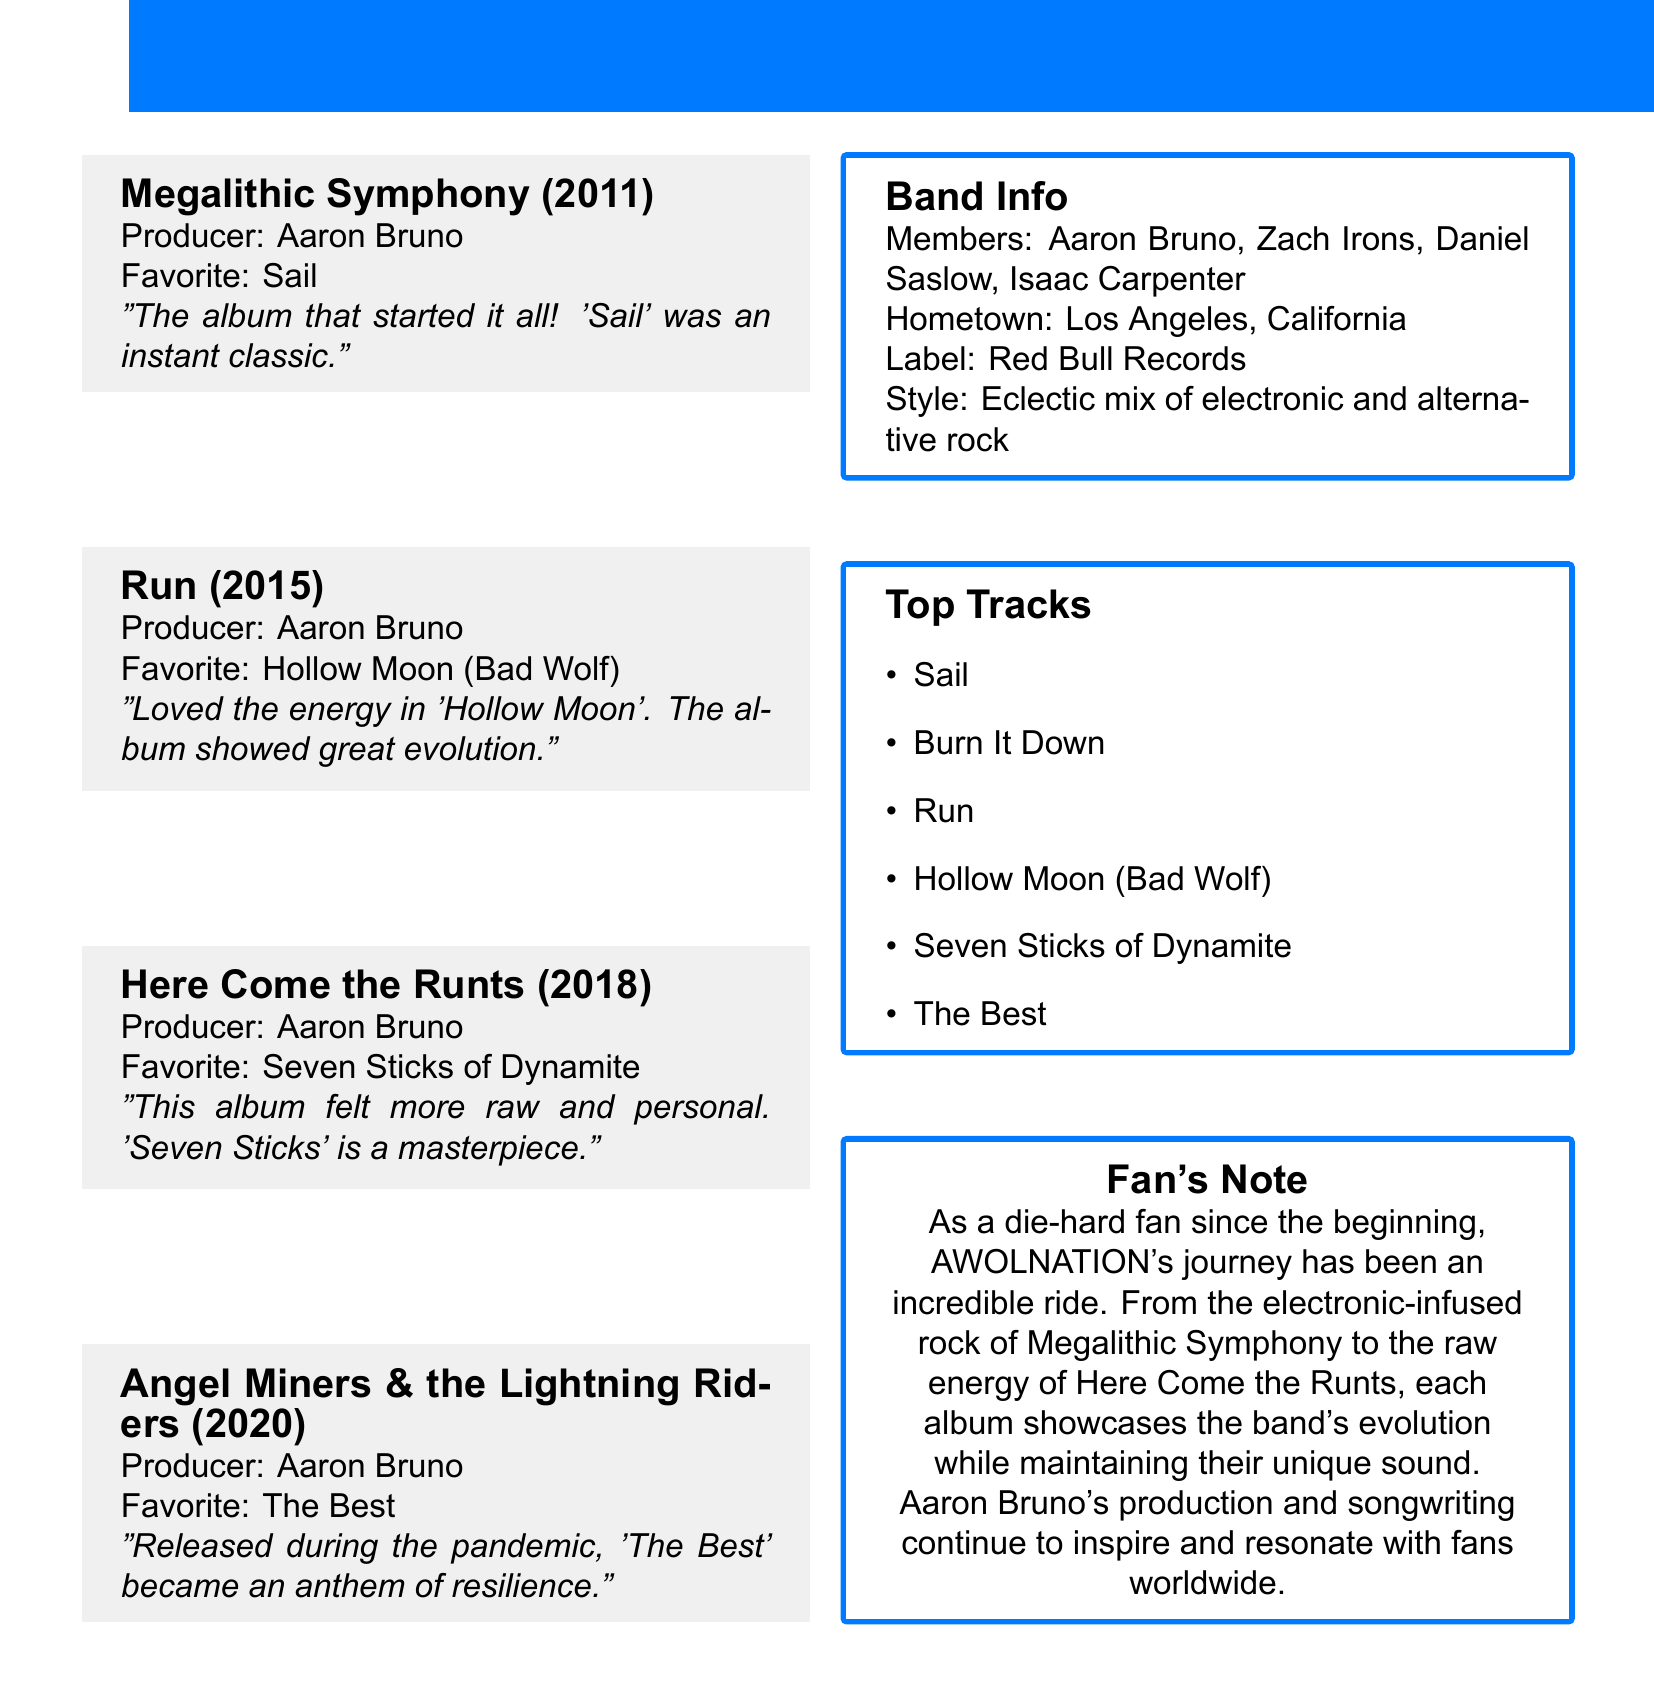What is the title of AWOLNATION's first album? The title of the first album listed is "Megalithic Symphony."
Answer: Megalithic Symphony In which year was "Run" released? The release date of "Run" is provided as March 17, 2015.
Answer: 2015 Who is the producer for all albums listed? The document specifies that Aaron Bruno is the producer for each of the albums.
Answer: Aaron Bruno What is the personal favorite song from the album "Here Come the Runts"? The personal favorite song from this album is listed as "Seven Sticks of Dynamite."
Answer: Seven Sticks of Dynamite How many tracks are listed in the album "Angel Miners & the Lightning Riders"? The document states five tracks are included in this album.
Answer: 5 Which song became an anthem of resilience during the pandemic? The document notes that "The Best" was highlighted as an anthem of resilience during the pandemic.
Answer: The Best What is the hometown of AWOLNATION? The document mentions that the band’s hometown is Los Angeles, California.
Answer: Los Angeles, California What type of music does AWOLNATION's style represent? The document describes the band's style as an "eclectic mix of electronic and alternative rock."
Answer: Eclectic mix of electronic and alternative rock 